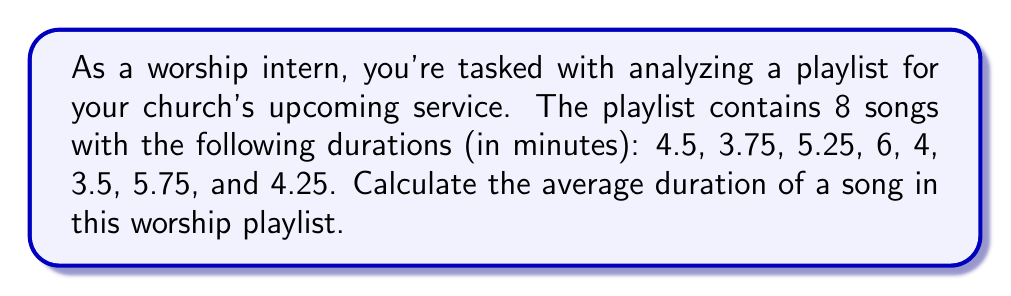Teach me how to tackle this problem. To find the average duration of the songs, we need to follow these steps:

1. Sum up all the durations:
   $$S = 4.5 + 3.75 + 5.25 + 6 + 4 + 3.5 + 5.75 + 4.25$$

2. Count the total number of songs:
   $$n = 8$$

3. Calculate the average using the formula:
   $$\text{Average} = \frac{\text{Sum of all values}}{\text{Number of values}} = \frac{S}{n}$$

Let's perform the calculations:

1. Sum of durations:
   $$S = 4.5 + 3.75 + 5.25 + 6 + 4 + 3.5 + 5.75 + 4.25 = 37$$

2. Number of songs:
   $$n = 8$$

3. Average duration:
   $$\text{Average} = \frac{S}{n} = \frac{37}{8} = 4.625$$

Therefore, the average duration of a song in this worship playlist is 4.625 minutes.
Answer: The average duration of a song in the worship playlist is 4.625 minutes. 